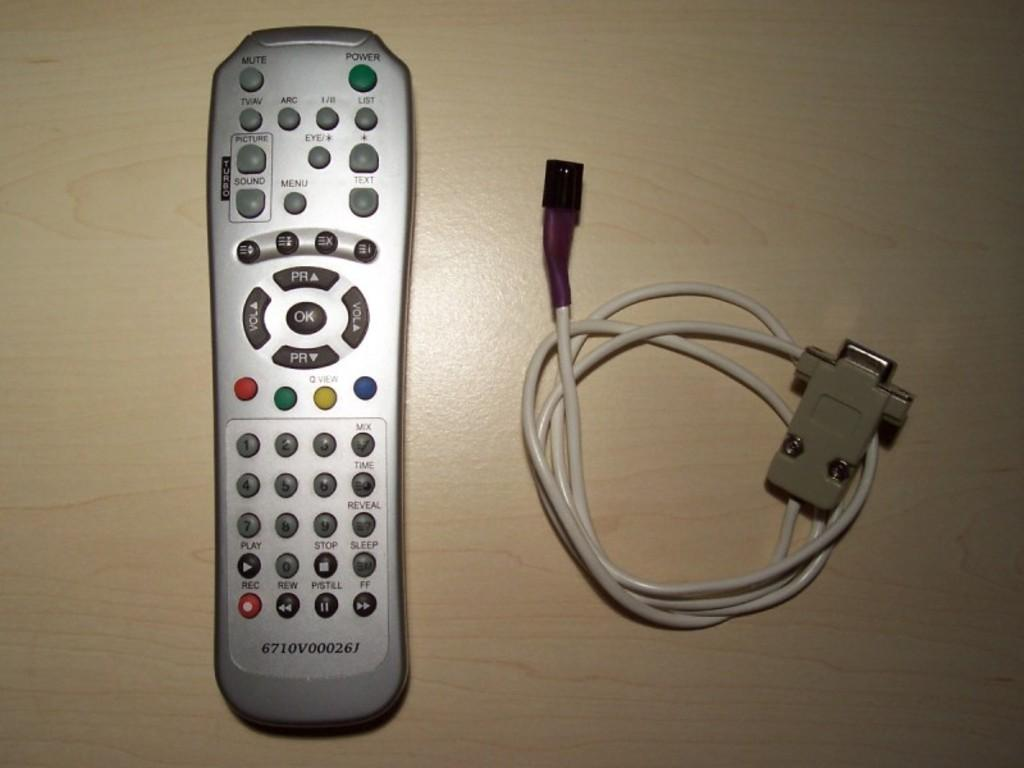<image>
Create a compact narrative representing the image presented. A remote on the table has a power button that is green 